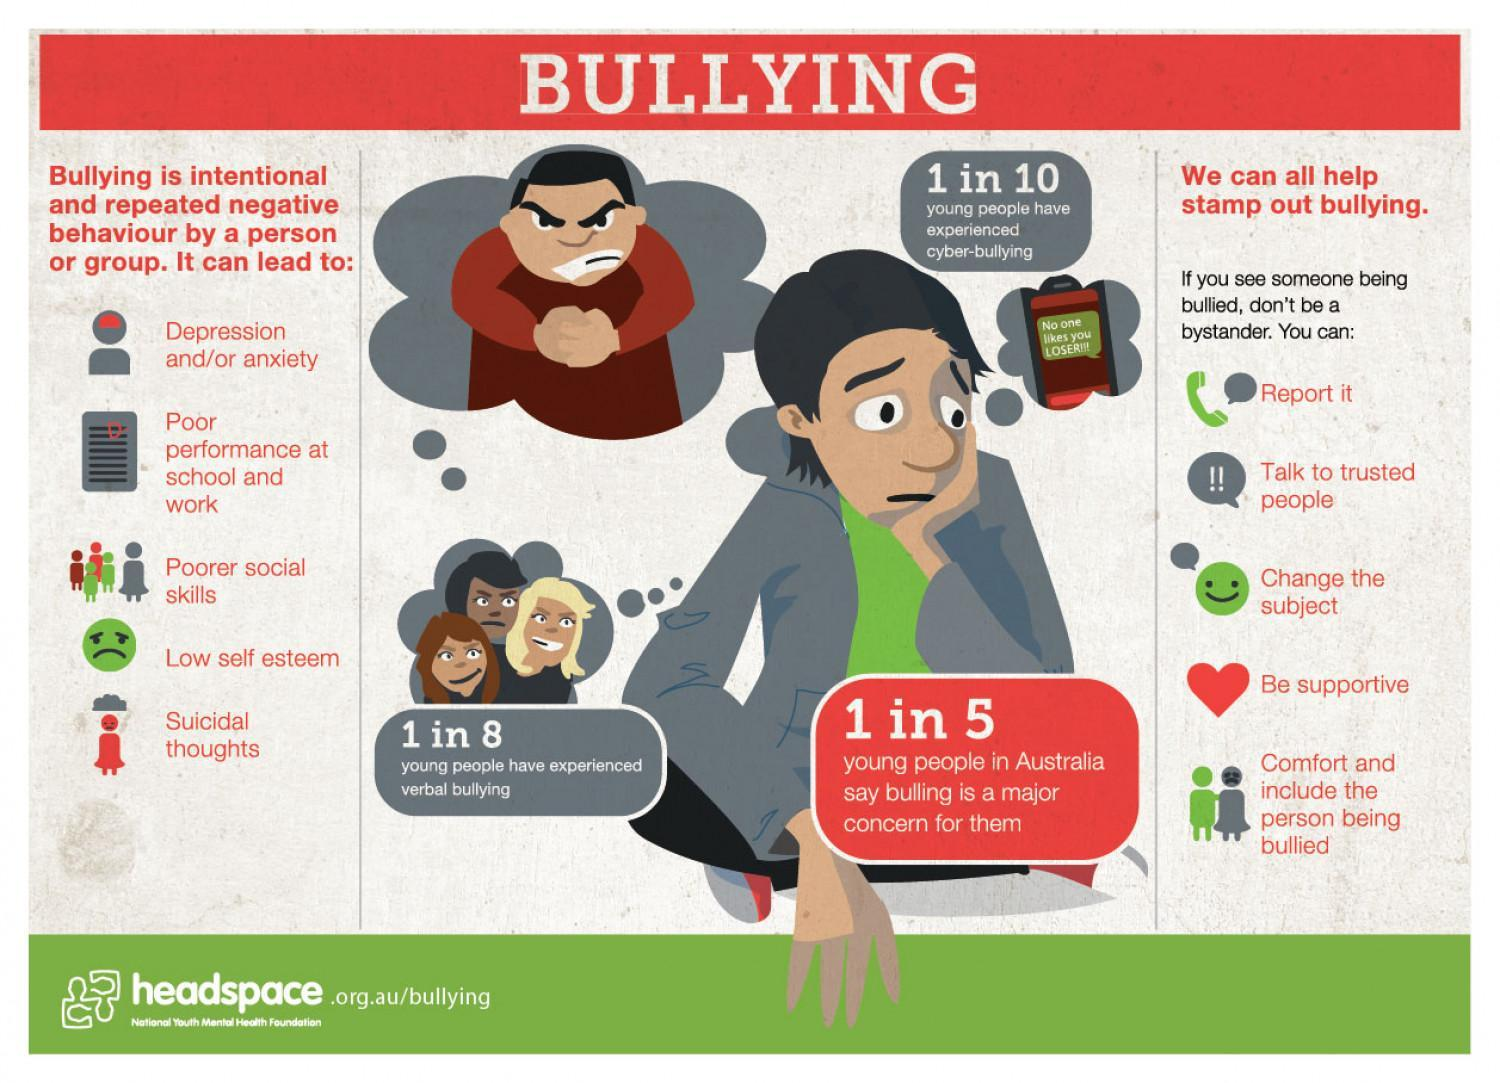What can lead to low self esteem?
Answer the question with a short phrase. Bullying How many young people have experienced verbal bullying? 1 in 8 